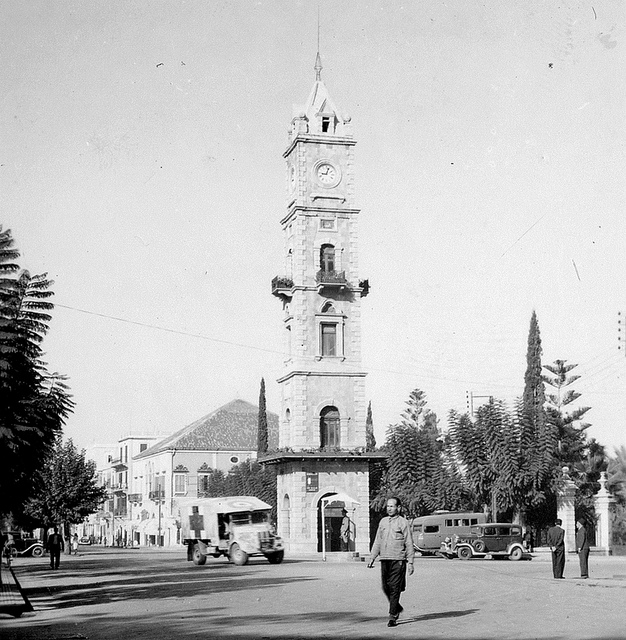<image>When was the picture taken of the people and white antique car parked near the curb? It is unclear when the picture was taken of the people and the white antique car parked near the curb. The time frame could range from the early 1900's to 1980. When was the picture taken of the people and white antique car parked near the curb? I don't know when the picture was taken of the people and white antique car parked near the curb. It can be either in 1980, in the 1950s, in the early 1900s, or in 1945. 